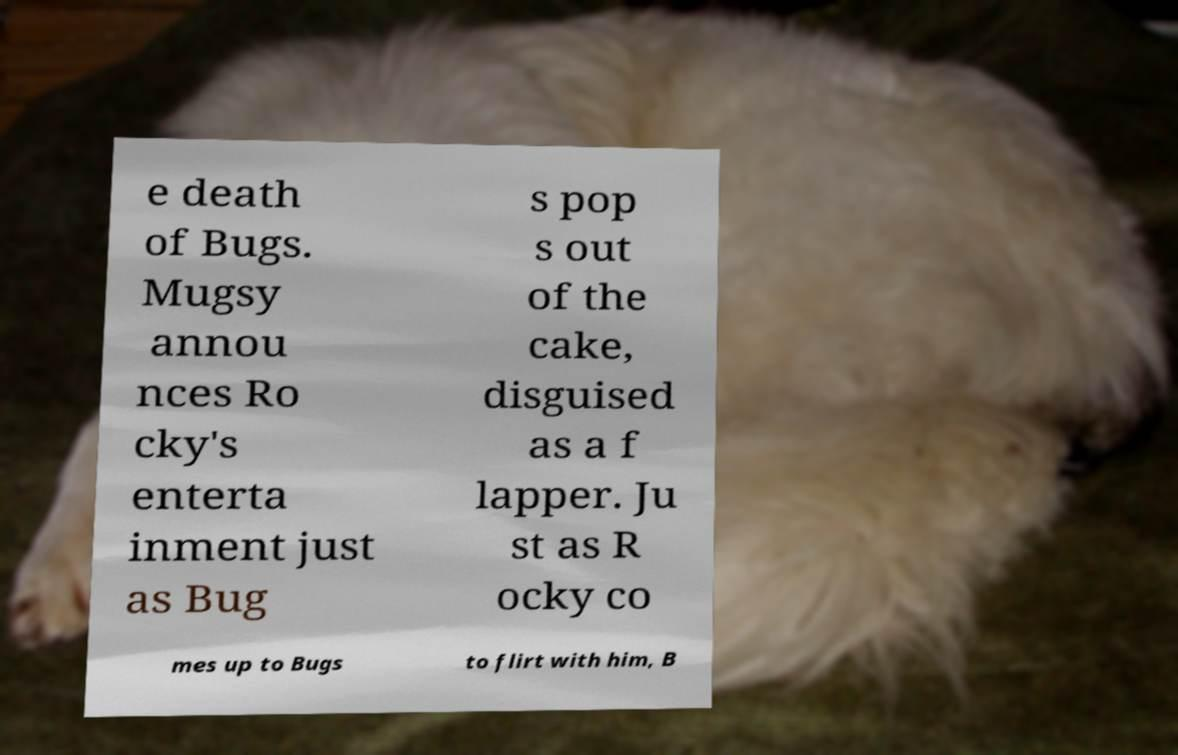Could you extract and type out the text from this image? e death of Bugs. Mugsy annou nces Ro cky's enterta inment just as Bug s pop s out of the cake, disguised as a f lapper. Ju st as R ocky co mes up to Bugs to flirt with him, B 